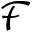Convert formula to latex. <formula><loc_0><loc_0><loc_500><loc_500>\mathcal { F }</formula> 